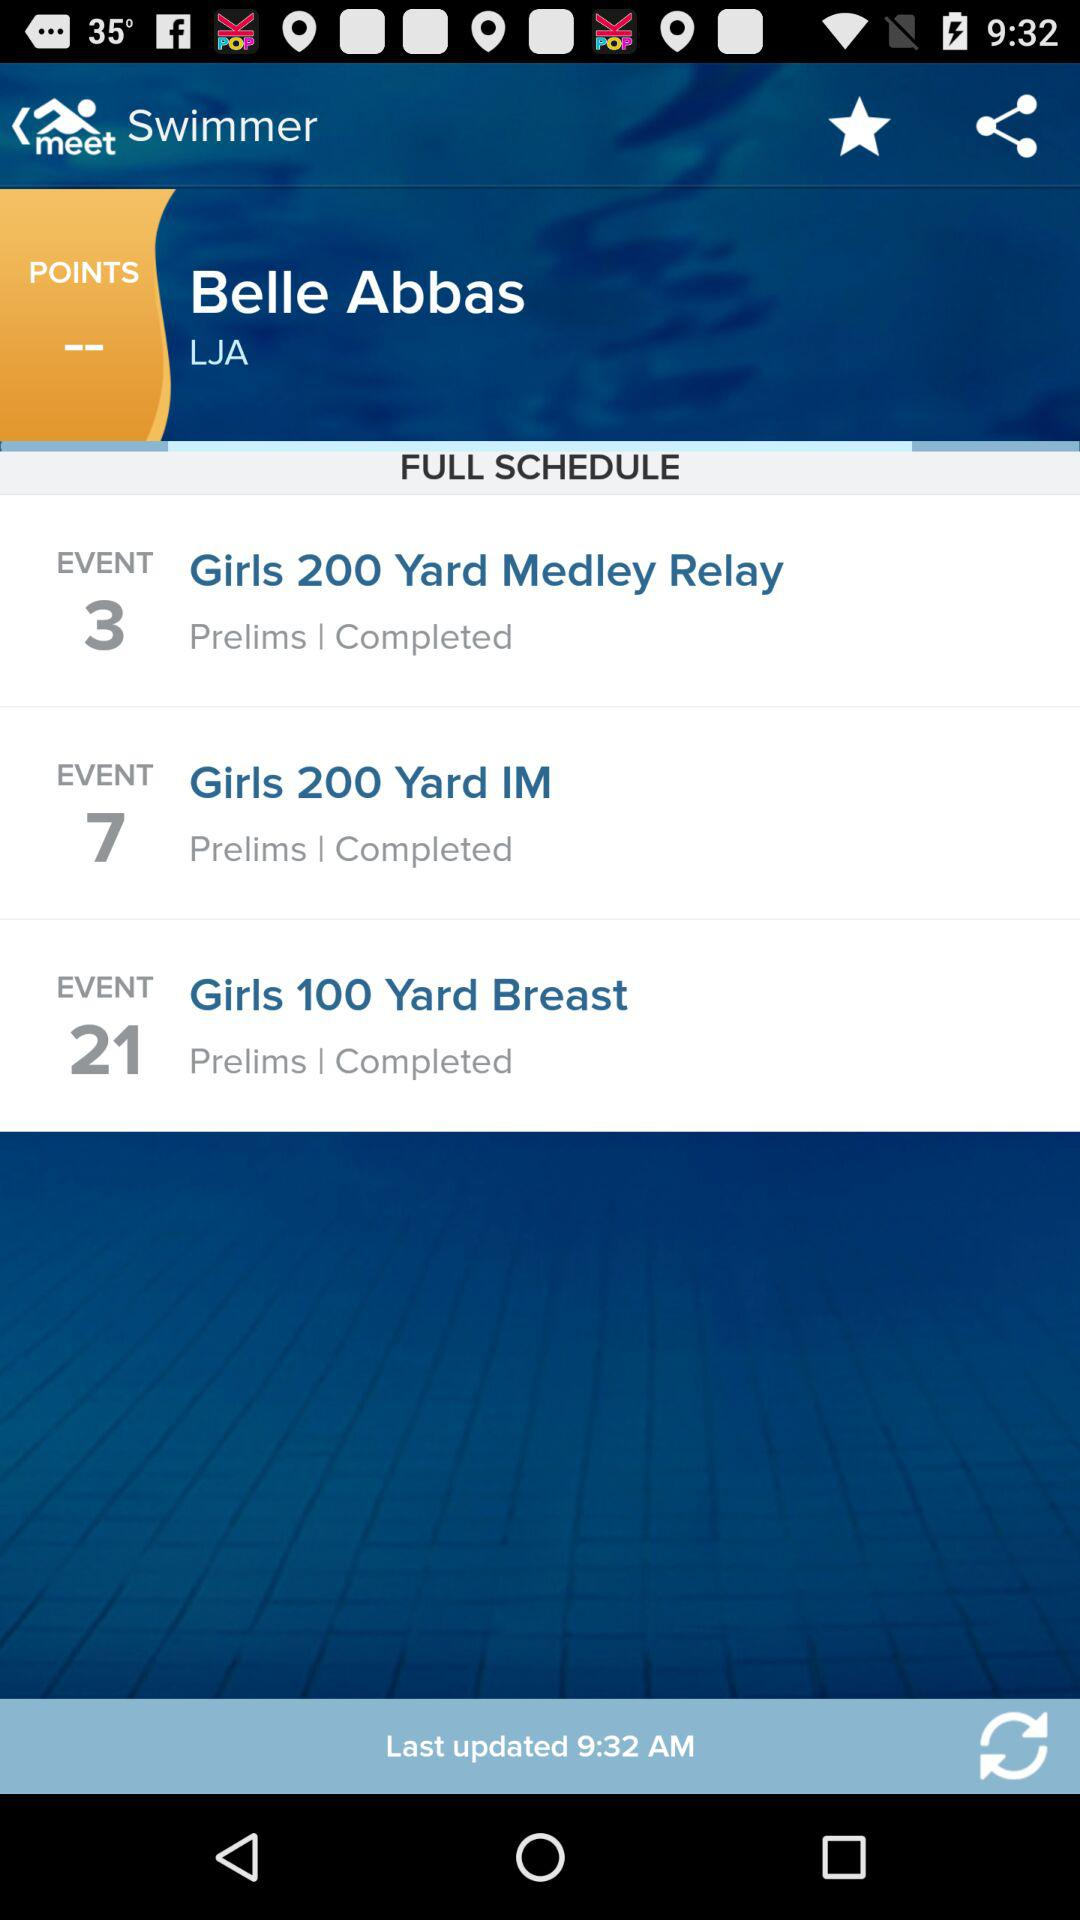What are the different available events? The different available events are "Girls 200 Yard Medley Relay", "Girls 200 Yard IM" and "Girls 100 Yard Breast". 